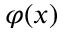<formula> <loc_0><loc_0><loc_500><loc_500>\varphi ( x )</formula> 